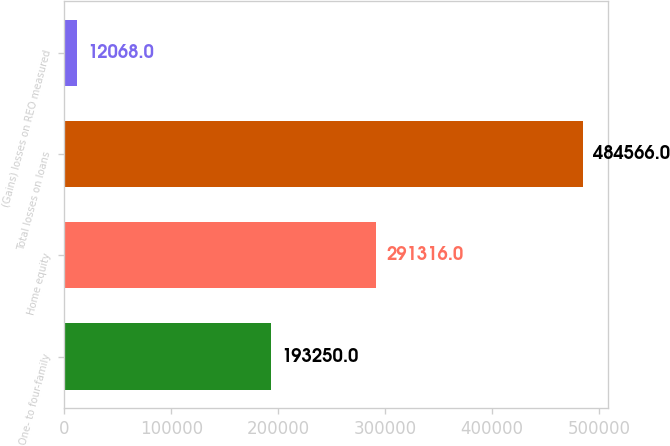<chart> <loc_0><loc_0><loc_500><loc_500><bar_chart><fcel>One- to four-family<fcel>Home equity<fcel>Total losses on loans<fcel>(Gains) losses on REO measured<nl><fcel>193250<fcel>291316<fcel>484566<fcel>12068<nl></chart> 